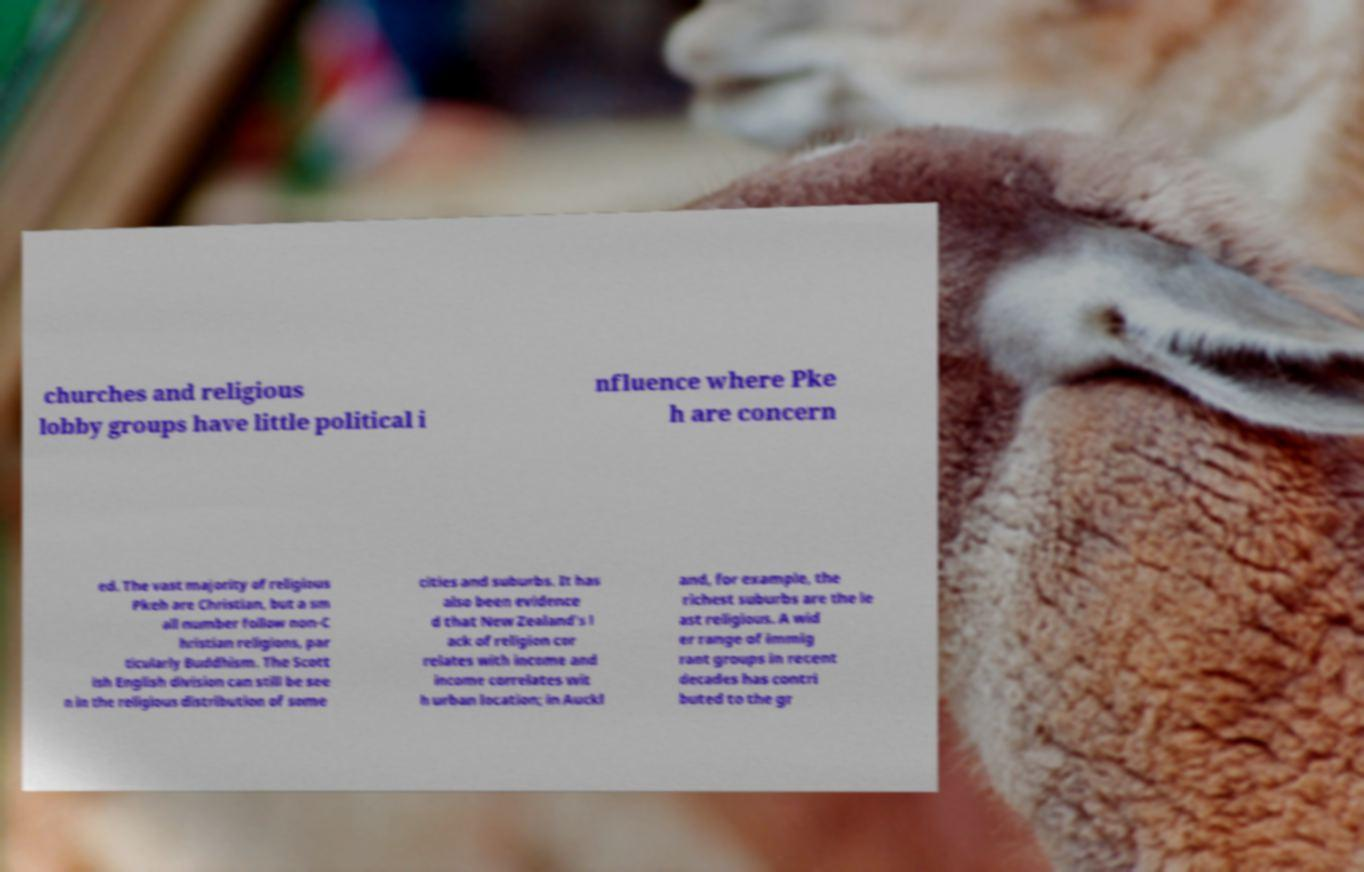Could you assist in decoding the text presented in this image and type it out clearly? churches and religious lobby groups have little political i nfluence where Pke h are concern ed. The vast majority of religious Pkeh are Christian, but a sm all number follow non-C hristian religions, par ticularly Buddhism. The Scott ish English division can still be see n in the religious distribution of some cities and suburbs. It has also been evidence d that New Zealand's l ack of religion cor relates with income and income correlates wit h urban location; in Auckl and, for example, the richest suburbs are the le ast religious. A wid er range of immig rant groups in recent decades has contri buted to the gr 